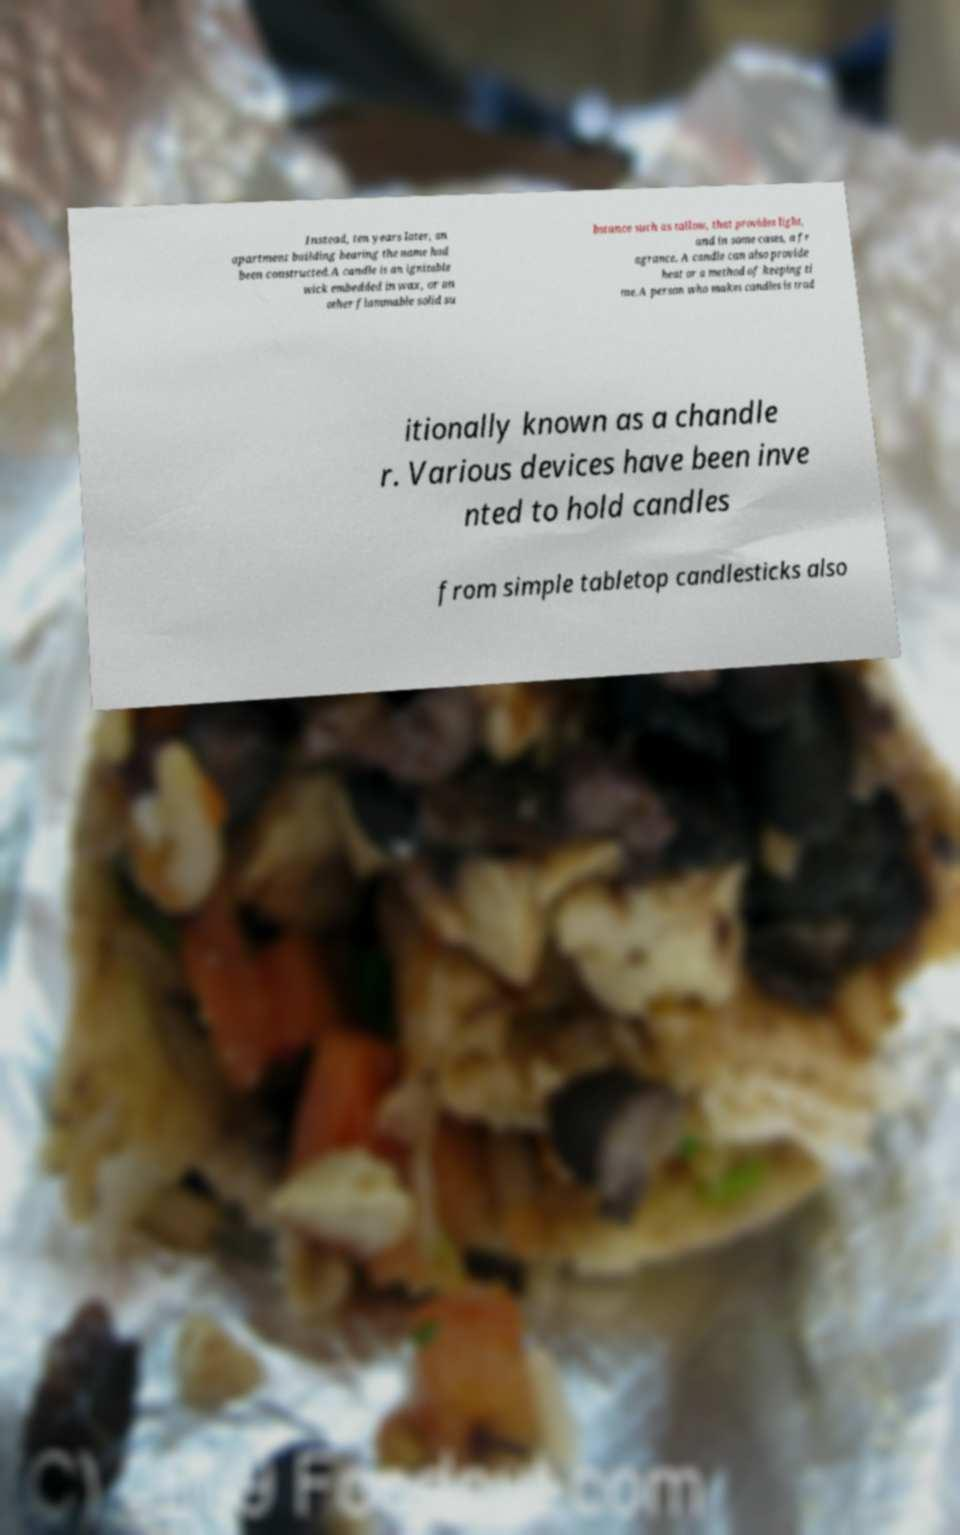What messages or text are displayed in this image? I need them in a readable, typed format. Instead, ten years later, an apartment building bearing the name had been constructed.A candle is an ignitable wick embedded in wax, or an other flammable solid su bstance such as tallow, that provides light, and in some cases, a fr agrance. A candle can also provide heat or a method of keeping ti me.A person who makes candles is trad itionally known as a chandle r. Various devices have been inve nted to hold candles from simple tabletop candlesticks also 